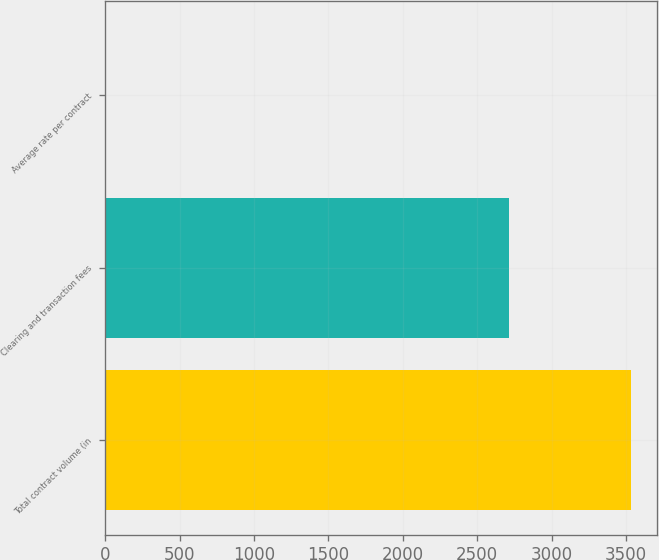<chart> <loc_0><loc_0><loc_500><loc_500><bar_chart><fcel>Total contract volume (in<fcel>Clearing and transaction fees<fcel>Average rate per contract<nl><fcel>3532.5<fcel>2716.9<fcel>0.77<nl></chart> 